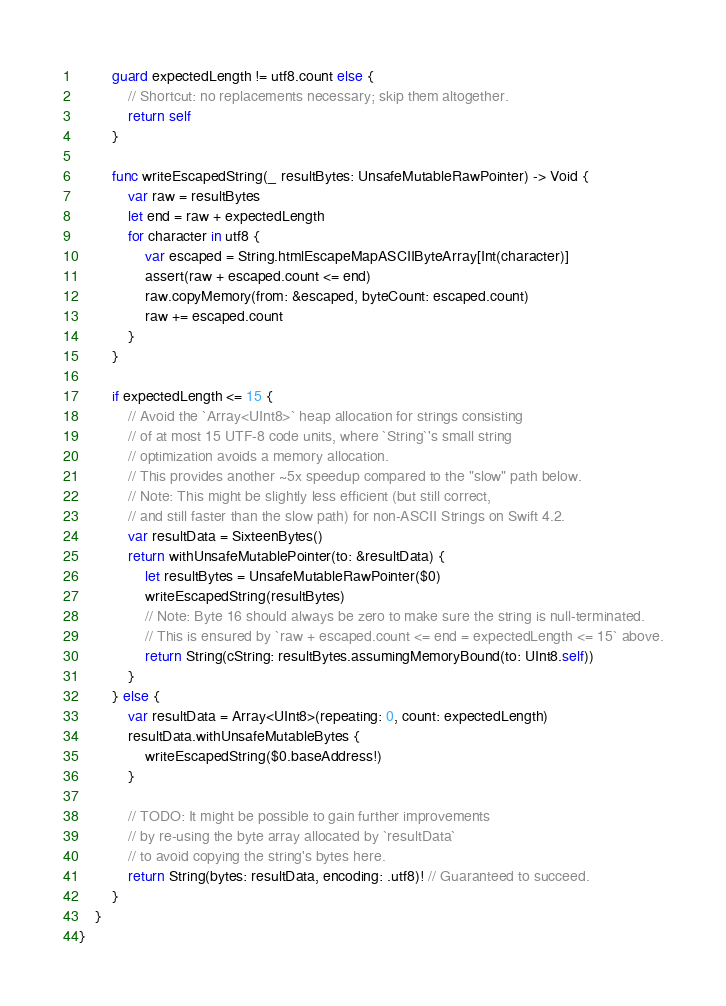Convert code to text. <code><loc_0><loc_0><loc_500><loc_500><_Swift_>
        guard expectedLength != utf8.count else {
            // Shortcut: no replacements necessary; skip them altogether.
            return self
        }

        func writeEscapedString(_ resultBytes: UnsafeMutableRawPointer) -> Void {
            var raw = resultBytes
            let end = raw + expectedLength
            for character in utf8 {
                var escaped = String.htmlEscapeMapASCIIByteArray[Int(character)]
                assert(raw + escaped.count <= end)
                raw.copyMemory(from: &escaped, byteCount: escaped.count)
                raw += escaped.count
            }
        }

        if expectedLength <= 15 {
            // Avoid the `Array<UInt8>` heap allocation for strings consisting
            // of at most 15 UTF-8 code units, where `String`'s small string
            // optimization avoids a memory allocation.
            // This provides another ~5x speedup compared to the "slow" path below.
            // Note: This might be slightly less efficient (but still correct,
            // and still faster than the slow path) for non-ASCII Strings on Swift 4.2.
            var resultData = SixteenBytes()
            return withUnsafeMutablePointer(to: &resultData) {
                let resultBytes = UnsafeMutableRawPointer($0)
                writeEscapedString(resultBytes)
                // Note: Byte 16 should always be zero to make sure the string is null-terminated.
                // This is ensured by `raw + escaped.count <= end = expectedLength <= 15` above.
                return String(cString: resultBytes.assumingMemoryBound(to: UInt8.self))
            }
        } else {
            var resultData = Array<UInt8>(repeating: 0, count: expectedLength)
            resultData.withUnsafeMutableBytes {
                writeEscapedString($0.baseAddress!)
            }

            // TODO: It might be possible to gain further improvements
            // by re-using the byte array allocated by `resultData`
            // to avoid copying the string's bytes here.
            return String(bytes: resultData, encoding: .utf8)! // Guaranteed to succeed.
        }
    }
}
</code> 